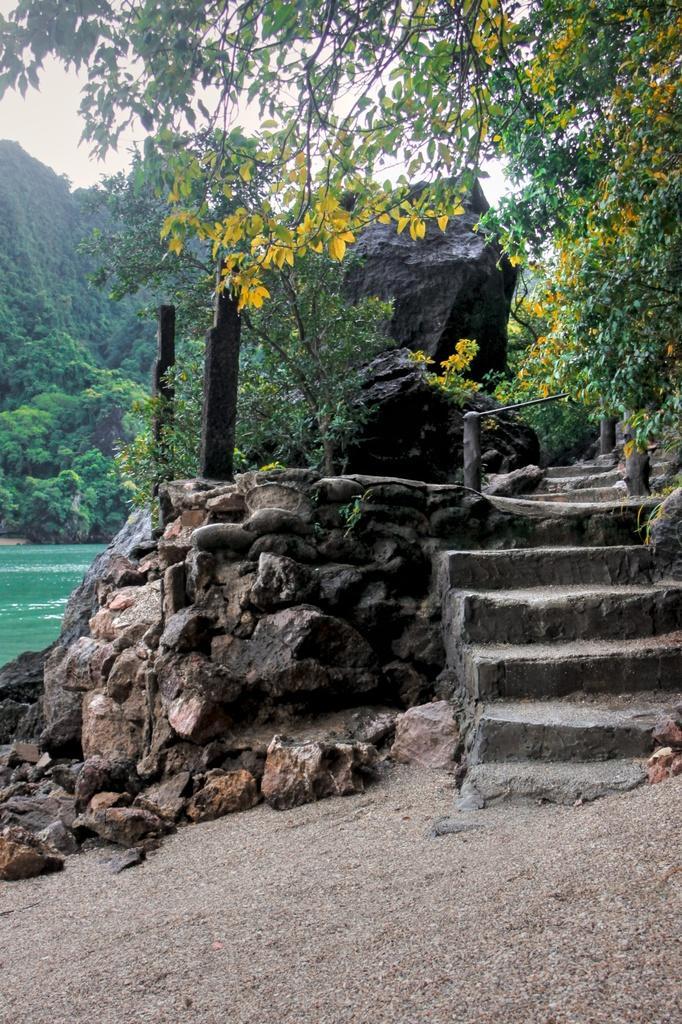Can you describe this image briefly? In the background we can see the sky, trees. In this picture we can see the rocks, stairs, wooden poles and the water. At the bottom portion of the picture we can see the sand. 